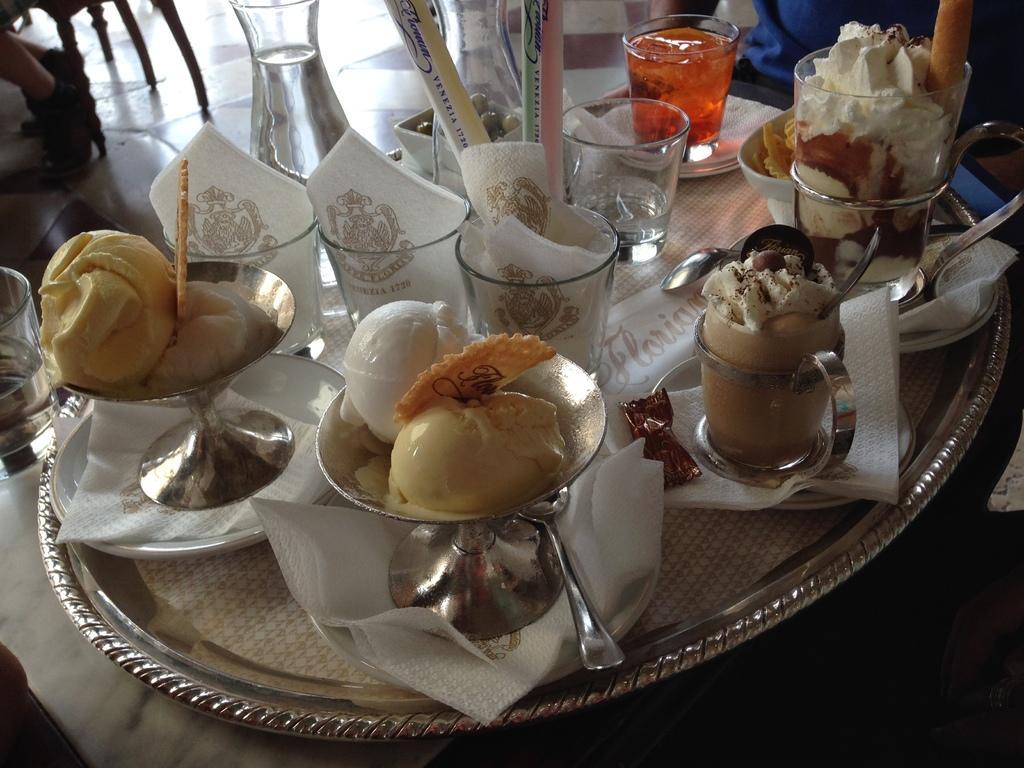Describe this image in one or two sentences. In this picture we can see a table, there is a plate and two glasses present on the table, we can see glasses, cups, tissue papers and spoons present in this place, we can see ice creams in these glasses. 